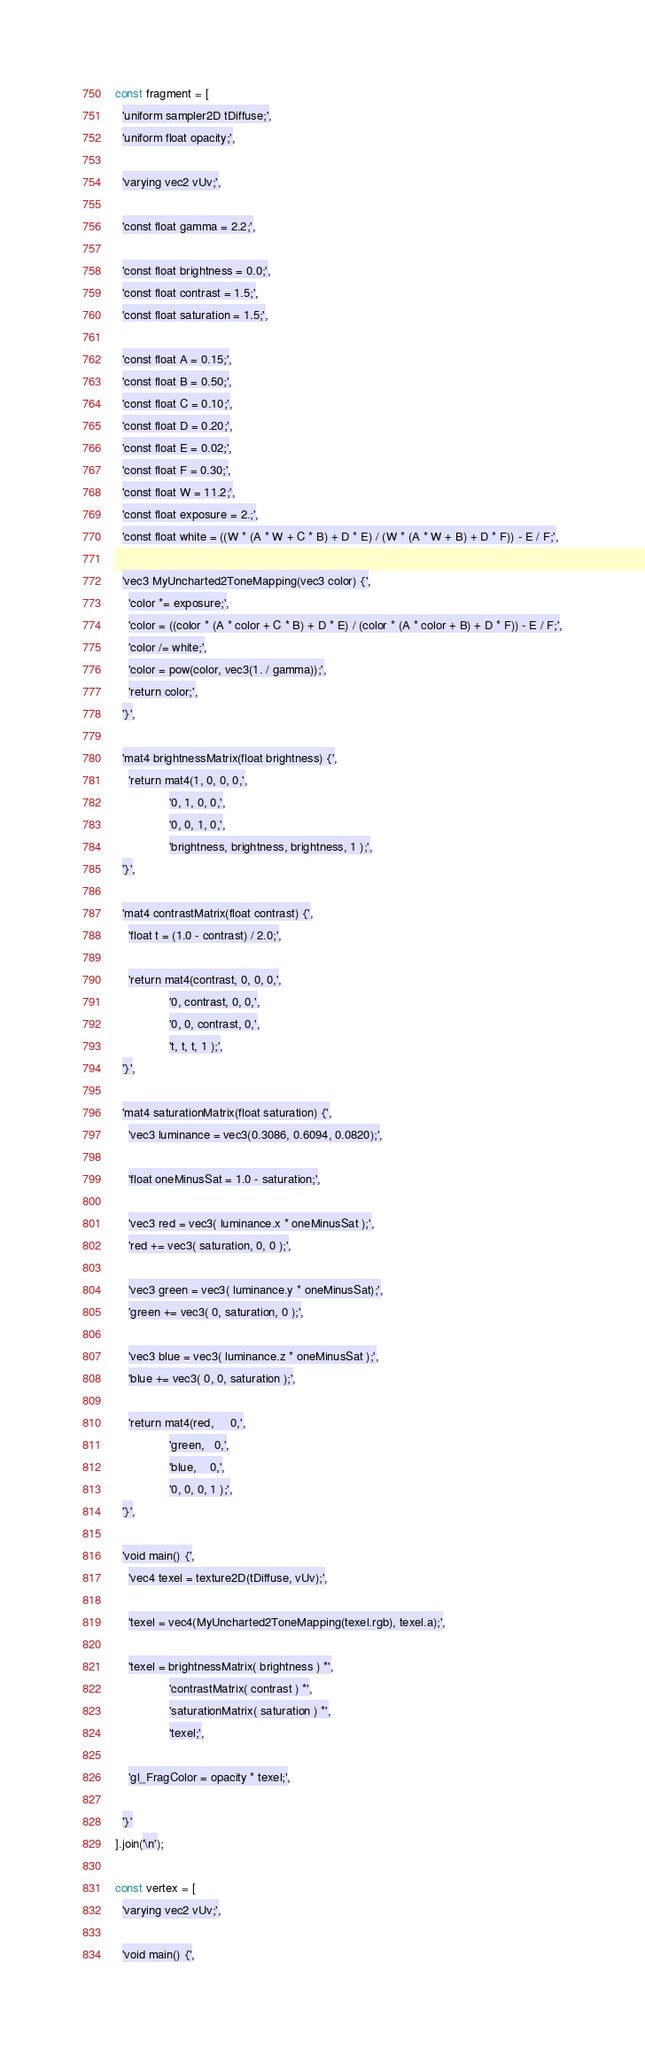Convert code to text. <code><loc_0><loc_0><loc_500><loc_500><_JavaScript_>const fragment = [
  'uniform sampler2D tDiffuse;',
  'uniform float opacity;',

  'varying vec2 vUv;',

  'const float gamma = 2.2;',

  'const float brightness = 0.0;',
  'const float contrast = 1.5;',
  'const float saturation = 1.5;',

  'const float A = 0.15;',
  'const float B = 0.50;',
  'const float C = 0.10;',
  'const float D = 0.20;',
  'const float E = 0.02;',
  'const float F = 0.30;',
  'const float W = 11.2;',
  'const float exposure = 2.;',
  'const float white = ((W * (A * W + C * B) + D * E) / (W * (A * W + B) + D * F)) - E / F;',

  'vec3 MyUncharted2ToneMapping(vec3 color) {',
    'color *= exposure;',
    'color = ((color * (A * color + C * B) + D * E) / (color * (A * color + B) + D * F)) - E / F;',
    'color /= white;',
    'color = pow(color, vec3(1. / gamma));',
    'return color;',
  '}',

  'mat4 brightnessMatrix(float brightness) {',
    'return mat4(1, 0, 0, 0,',
                '0, 1, 0, 0,',
                '0, 0, 1, 0,',
                'brightness, brightness, brightness, 1 );',
  '}',

  'mat4 contrastMatrix(float contrast) {',
    'float t = (1.0 - contrast) / 2.0;',

    'return mat4(contrast, 0, 0, 0,',
                '0, contrast, 0, 0,',
                '0, 0, contrast, 0,',
                't, t, t, 1 );',
  '}',

  'mat4 saturationMatrix(float saturation) {',
    'vec3 luminance = vec3(0.3086, 0.6094, 0.0820);',

    'float oneMinusSat = 1.0 - saturation;',

    'vec3 red = vec3( luminance.x * oneMinusSat );',
    'red += vec3( saturation, 0, 0 );',

    'vec3 green = vec3( luminance.y * oneMinusSat);',
    'green += vec3( 0, saturation, 0 );',

    'vec3 blue = vec3( luminance.z * oneMinusSat );',
    'blue += vec3( 0, 0, saturation );',

    'return mat4(red,     0,',
                'green,   0,',
                'blue,    0,',
                '0, 0, 0, 1 );',
  '}',

  'void main() {',
    'vec4 texel = texture2D(tDiffuse, vUv);',

    'texel = vec4(MyUncharted2ToneMapping(texel.rgb), texel.a);',

    'texel = brightnessMatrix( brightness ) *',
        		'contrastMatrix( contrast ) *',
        		'saturationMatrix( saturation ) *',
        		'texel;',

    'gl_FragColor = opacity * texel;',

  '}'
].join('\n');

const vertex = [
  'varying vec2 vUv;',

  'void main() {',
</code> 